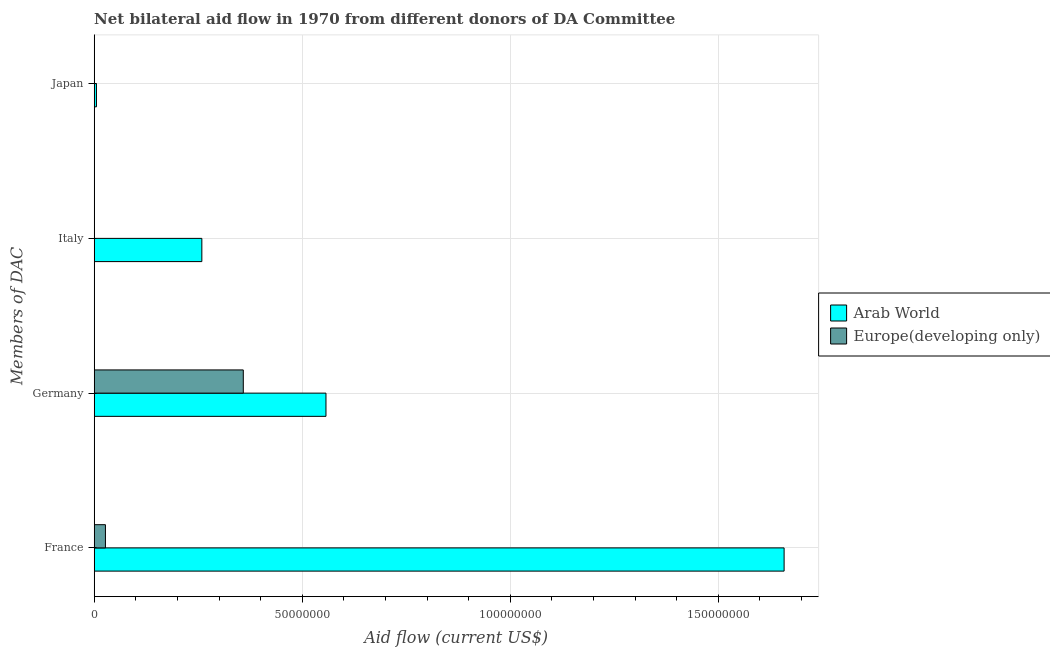How many different coloured bars are there?
Give a very brief answer. 2. How many bars are there on the 3rd tick from the top?
Provide a short and direct response. 2. How many bars are there on the 4th tick from the bottom?
Ensure brevity in your answer.  1. What is the label of the 2nd group of bars from the top?
Offer a very short reply. Italy. What is the amount of aid given by germany in Europe(developing only)?
Keep it short and to the point. 3.58e+07. Across all countries, what is the maximum amount of aid given by france?
Ensure brevity in your answer.  1.66e+08. Across all countries, what is the minimum amount of aid given by italy?
Provide a succinct answer. 0. In which country was the amount of aid given by japan maximum?
Offer a very short reply. Arab World. What is the total amount of aid given by germany in the graph?
Offer a very short reply. 9.15e+07. What is the difference between the amount of aid given by germany in Arab World and that in Europe(developing only)?
Offer a terse response. 1.99e+07. What is the difference between the amount of aid given by france in Europe(developing only) and the amount of aid given by italy in Arab World?
Your answer should be very brief. -2.32e+07. What is the average amount of aid given by italy per country?
Provide a succinct answer. 1.29e+07. What is the difference between the amount of aid given by france and amount of aid given by italy in Arab World?
Make the answer very short. 1.40e+08. What is the ratio of the amount of aid given by france in Europe(developing only) to that in Arab World?
Keep it short and to the point. 0.02. Is the amount of aid given by germany in Europe(developing only) less than that in Arab World?
Offer a very short reply. Yes. Is the difference between the amount of aid given by france in Europe(developing only) and Arab World greater than the difference between the amount of aid given by germany in Europe(developing only) and Arab World?
Give a very brief answer. No. What is the difference between the highest and the second highest amount of aid given by france?
Provide a short and direct response. 1.63e+08. What is the difference between the highest and the lowest amount of aid given by japan?
Keep it short and to the point. 5.40e+05. Is it the case that in every country, the sum of the amount of aid given by france and amount of aid given by germany is greater than the amount of aid given by italy?
Your answer should be compact. Yes. How many countries are there in the graph?
Provide a short and direct response. 2. Are the values on the major ticks of X-axis written in scientific E-notation?
Offer a terse response. No. Does the graph contain any zero values?
Your answer should be compact. Yes. Does the graph contain grids?
Your response must be concise. Yes. What is the title of the graph?
Give a very brief answer. Net bilateral aid flow in 1970 from different donors of DA Committee. What is the label or title of the X-axis?
Provide a short and direct response. Aid flow (current US$). What is the label or title of the Y-axis?
Give a very brief answer. Members of DAC. What is the Aid flow (current US$) in Arab World in France?
Provide a succinct answer. 1.66e+08. What is the Aid flow (current US$) of Europe(developing only) in France?
Your answer should be very brief. 2.70e+06. What is the Aid flow (current US$) of Arab World in Germany?
Your answer should be very brief. 5.57e+07. What is the Aid flow (current US$) of Europe(developing only) in Germany?
Ensure brevity in your answer.  3.58e+07. What is the Aid flow (current US$) in Arab World in Italy?
Offer a terse response. 2.59e+07. What is the Aid flow (current US$) in Arab World in Japan?
Your answer should be compact. 5.40e+05. Across all Members of DAC, what is the maximum Aid flow (current US$) of Arab World?
Offer a very short reply. 1.66e+08. Across all Members of DAC, what is the maximum Aid flow (current US$) of Europe(developing only)?
Your response must be concise. 3.58e+07. Across all Members of DAC, what is the minimum Aid flow (current US$) of Arab World?
Provide a short and direct response. 5.40e+05. Across all Members of DAC, what is the minimum Aid flow (current US$) in Europe(developing only)?
Give a very brief answer. 0. What is the total Aid flow (current US$) of Arab World in the graph?
Provide a short and direct response. 2.48e+08. What is the total Aid flow (current US$) in Europe(developing only) in the graph?
Your answer should be compact. 3.85e+07. What is the difference between the Aid flow (current US$) of Arab World in France and that in Germany?
Keep it short and to the point. 1.10e+08. What is the difference between the Aid flow (current US$) of Europe(developing only) in France and that in Germany?
Your answer should be compact. -3.31e+07. What is the difference between the Aid flow (current US$) of Arab World in France and that in Italy?
Give a very brief answer. 1.40e+08. What is the difference between the Aid flow (current US$) in Arab World in France and that in Japan?
Offer a terse response. 1.65e+08. What is the difference between the Aid flow (current US$) in Arab World in Germany and that in Italy?
Give a very brief answer. 2.98e+07. What is the difference between the Aid flow (current US$) in Arab World in Germany and that in Japan?
Provide a succinct answer. 5.52e+07. What is the difference between the Aid flow (current US$) of Arab World in Italy and that in Japan?
Offer a terse response. 2.53e+07. What is the difference between the Aid flow (current US$) in Arab World in France and the Aid flow (current US$) in Europe(developing only) in Germany?
Make the answer very short. 1.30e+08. What is the average Aid flow (current US$) of Arab World per Members of DAC?
Ensure brevity in your answer.  6.20e+07. What is the average Aid flow (current US$) in Europe(developing only) per Members of DAC?
Ensure brevity in your answer.  9.63e+06. What is the difference between the Aid flow (current US$) of Arab World and Aid flow (current US$) of Europe(developing only) in France?
Keep it short and to the point. 1.63e+08. What is the difference between the Aid flow (current US$) in Arab World and Aid flow (current US$) in Europe(developing only) in Germany?
Provide a succinct answer. 1.99e+07. What is the ratio of the Aid flow (current US$) in Arab World in France to that in Germany?
Your response must be concise. 2.98. What is the ratio of the Aid flow (current US$) in Europe(developing only) in France to that in Germany?
Provide a succinct answer. 0.08. What is the ratio of the Aid flow (current US$) in Arab World in France to that in Italy?
Keep it short and to the point. 6.41. What is the ratio of the Aid flow (current US$) of Arab World in France to that in Japan?
Your response must be concise. 307.04. What is the ratio of the Aid flow (current US$) of Arab World in Germany to that in Italy?
Keep it short and to the point. 2.15. What is the ratio of the Aid flow (current US$) in Arab World in Germany to that in Japan?
Your answer should be very brief. 103.15. What is the ratio of the Aid flow (current US$) in Arab World in Italy to that in Japan?
Offer a terse response. 47.91. What is the difference between the highest and the second highest Aid flow (current US$) of Arab World?
Offer a terse response. 1.10e+08. What is the difference between the highest and the lowest Aid flow (current US$) of Arab World?
Your response must be concise. 1.65e+08. What is the difference between the highest and the lowest Aid flow (current US$) of Europe(developing only)?
Keep it short and to the point. 3.58e+07. 